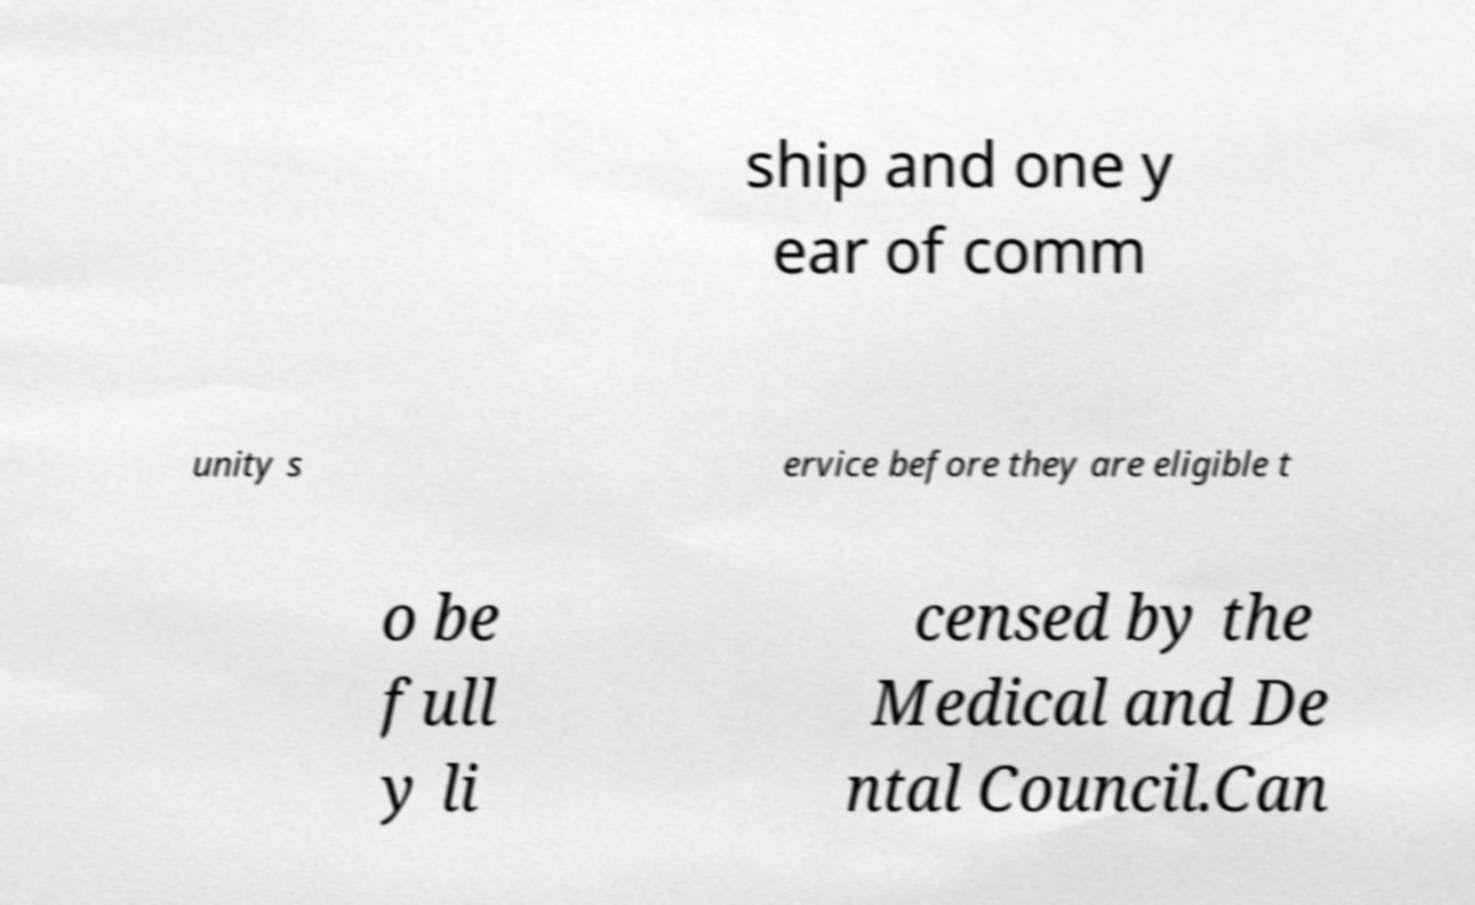There's text embedded in this image that I need extracted. Can you transcribe it verbatim? ship and one y ear of comm unity s ervice before they are eligible t o be full y li censed by the Medical and De ntal Council.Can 